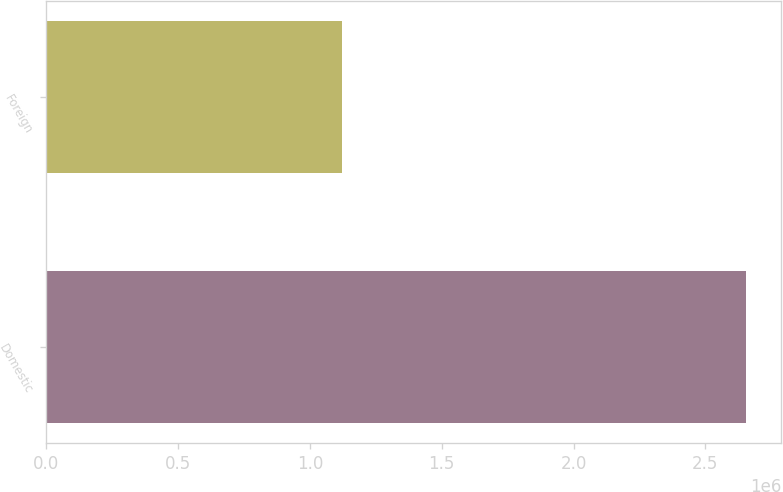Convert chart. <chart><loc_0><loc_0><loc_500><loc_500><bar_chart><fcel>Domestic<fcel>Foreign<nl><fcel>2.65544e+06<fcel>1.12153e+06<nl></chart> 